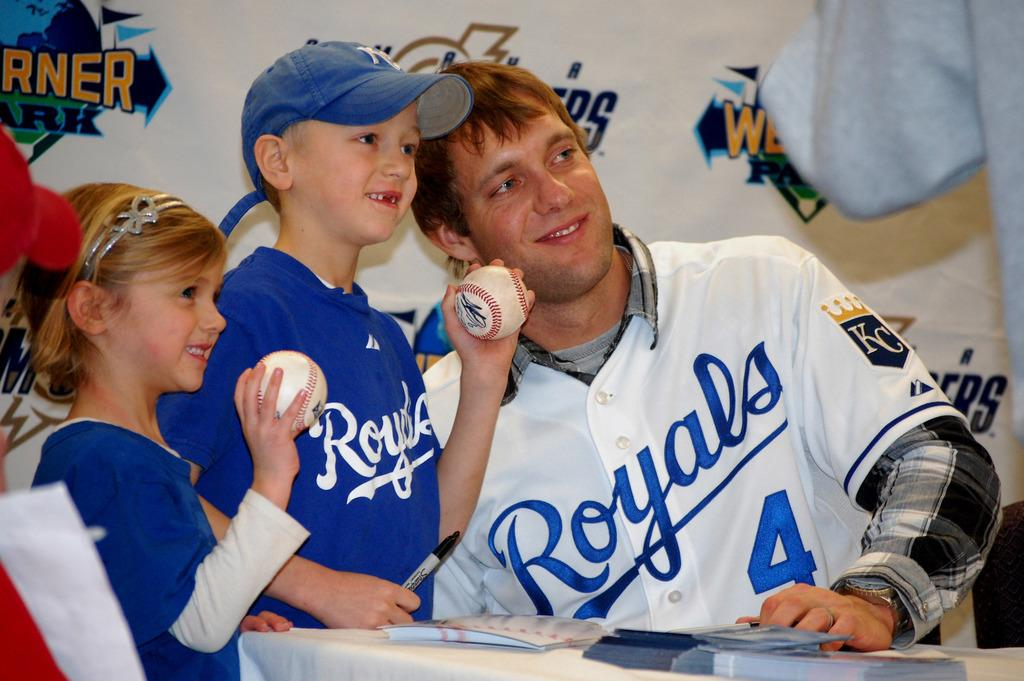<image>
Describe the image concisely. A player for the Royals poses with a couple of young fans. 